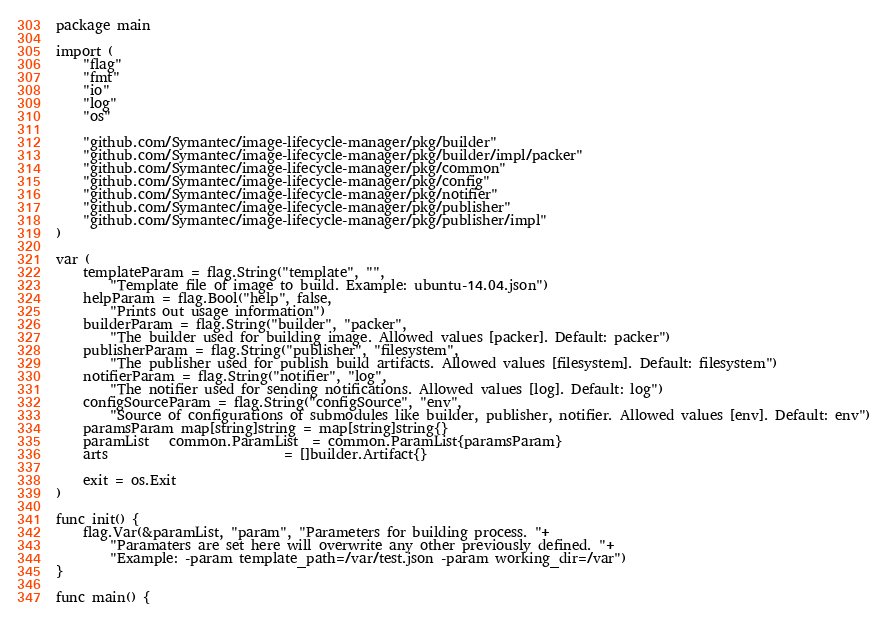<code> <loc_0><loc_0><loc_500><loc_500><_Go_>package main

import (
	"flag"
	"fmt"
	"io"
	"log"
	"os"

	"github.com/Symantec/image-lifecycle-manager/pkg/builder"
	"github.com/Symantec/image-lifecycle-manager/pkg/builder/impl/packer"
	"github.com/Symantec/image-lifecycle-manager/pkg/common"
	"github.com/Symantec/image-lifecycle-manager/pkg/config"
	"github.com/Symantec/image-lifecycle-manager/pkg/notifier"
	"github.com/Symantec/image-lifecycle-manager/pkg/publisher"
	"github.com/Symantec/image-lifecycle-manager/pkg/publisher/impl"
)

var (
	templateParam = flag.String("template", "",
		"Template file of image to build. Example: ubuntu-14.04.json")
	helpParam = flag.Bool("help", false,
		"Prints out usage information")
	builderParam = flag.String("builder", "packer",
		"The builder used for building image. Allowed values [packer]. Default: packer")
	publisherParam = flag.String("publisher", "filesystem",
		"The publisher used for publish build artifacts. Allowed values [filesystem]. Default: filesystem")
	notifierParam = flag.String("notifier", "log",
		"The notifier used for sending notifications. Allowed values [log]. Default: log")
	configSourceParam = flag.String("configSource", "env",
		"Source of configurations of submodules like builder, publisher, notifier. Allowed values [env]. Default: env")
	paramsParam map[string]string = map[string]string{}
	paramList   common.ParamList  = common.ParamList{paramsParam}
	arts                          = []builder.Artifact{}

	exit = os.Exit
)

func init() {
	flag.Var(&paramList, "param", "Parameters for building process. "+
		"Paramaters are set here will overwrite any other previously defined. "+
		"Example: -param template_path=/var/test.json -param working_dir=/var")
}

func main() {</code> 